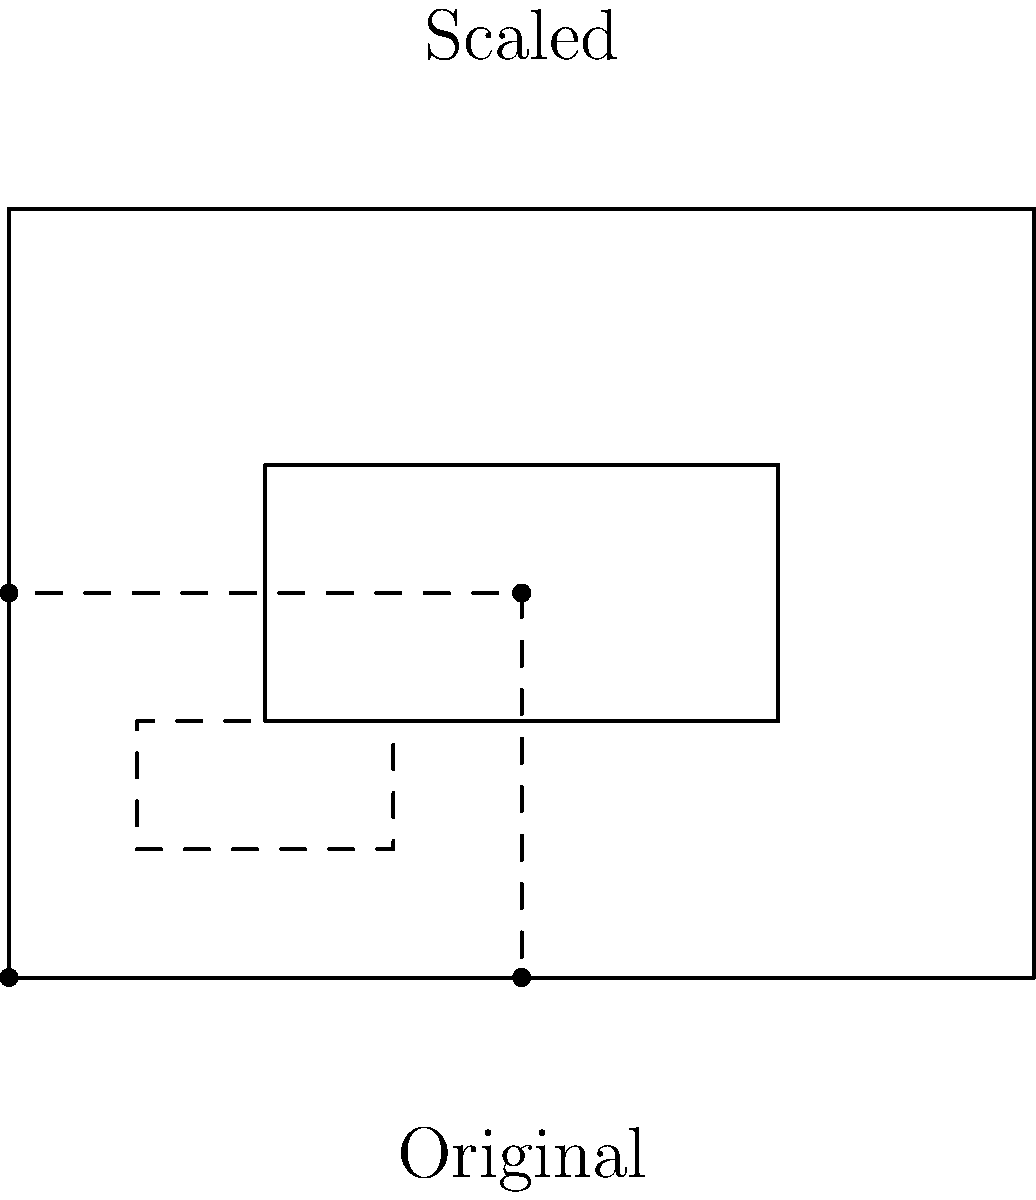You're tasked with scaling down a rectangular logo for various promotional materials. The original logo is a 4 cm by 3 cm rectangle with a smaller rectangle inside it. If you need to reduce the logo to half its original size while maintaining its proportions, what would be the dimensions of the scaled-down outer rectangle? To solve this problem, we'll follow these steps:

1. Identify the original dimensions:
   - The original outer rectangle is 4 cm wide and 3 cm tall.

2. Understand the scaling factor:
   - We need to reduce the logo to half its original size.
   - This means we'll use a scaling factor of 0.5 or 1/2.

3. Apply the scaling factor to both dimensions:
   - New width = Original width × Scaling factor
   - New width = 4 cm × 0.5 = 2 cm

   - New height = Original height × Scaling factor
   - New height = 3 cm × 0.5 = 1.5 cm

4. Verify the proportions:
   - Original ratio: 4:3
   - New ratio: 2:1.5, which simplifies to 4:3

Therefore, the scaled-down outer rectangle will have dimensions of 2 cm by 1.5 cm, maintaining the original proportions.
Answer: $2 \text{ cm} \times 1.5 \text{ cm}$ 